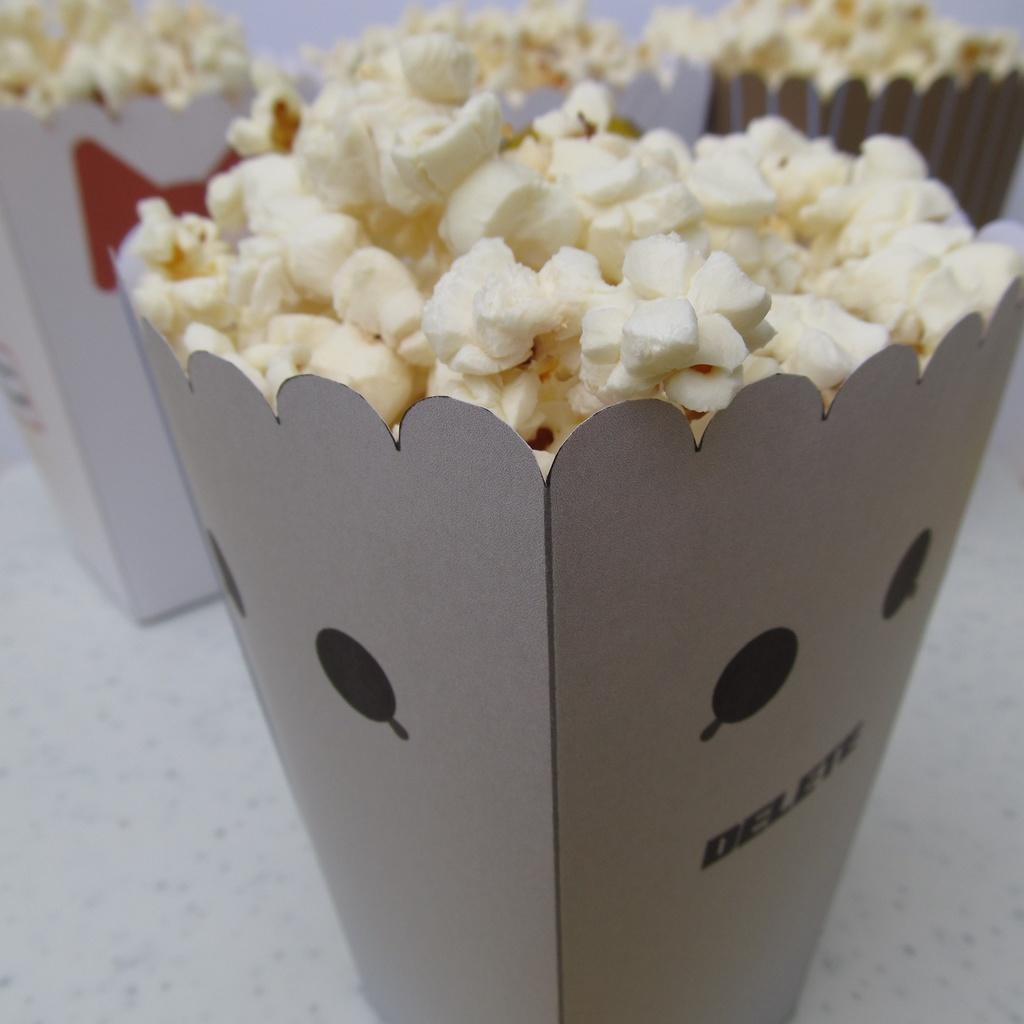What type of food is contained in the boxes in the image? The boxes in the image contain popcorn. Where are the popcorn boxes placed? The popcorn boxes are placed on a white table. Can you see a crown on the floor in the image? There is no crown present in the image, and the floor is not visible in the provided facts. 